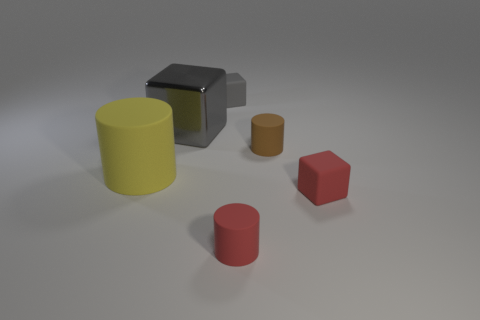Can you describe the shapes and colors of the objects in the image? Certainly! There are four objects in the image: a large yellow cylinder, a smaller red cylinder, a tiny brown cylinder, and a medium-sized cube with a metallic grey appearance. 